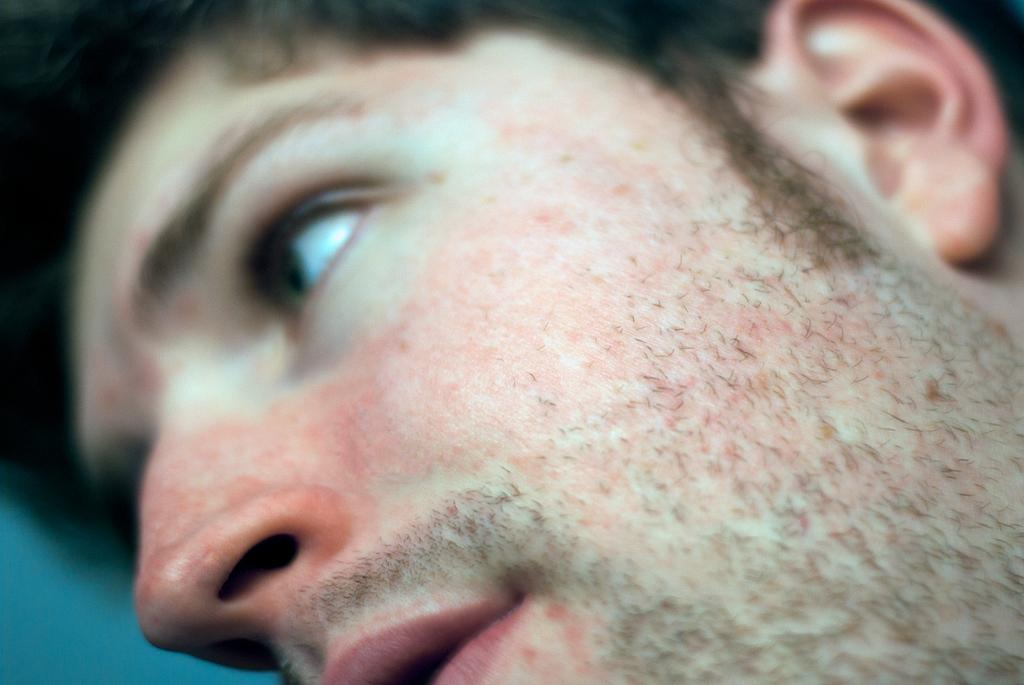What is the main subject of the image? There is a person in the image. What can be seen on the left side of the image? There is a blue surface on the left side of the image. Can you see an example of a camp on the person's tongue in the image? There is no camp or tongue visible in the image, and therefore no such example can be observed. 